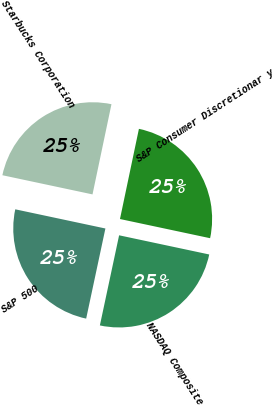Convert chart to OTSL. <chart><loc_0><loc_0><loc_500><loc_500><pie_chart><fcel>Starbucks Corporation<fcel>S&P 500<fcel>NASDAQ Composite<fcel>S&P Consumer Discretionar y<nl><fcel>24.96%<fcel>24.99%<fcel>25.01%<fcel>25.04%<nl></chart> 